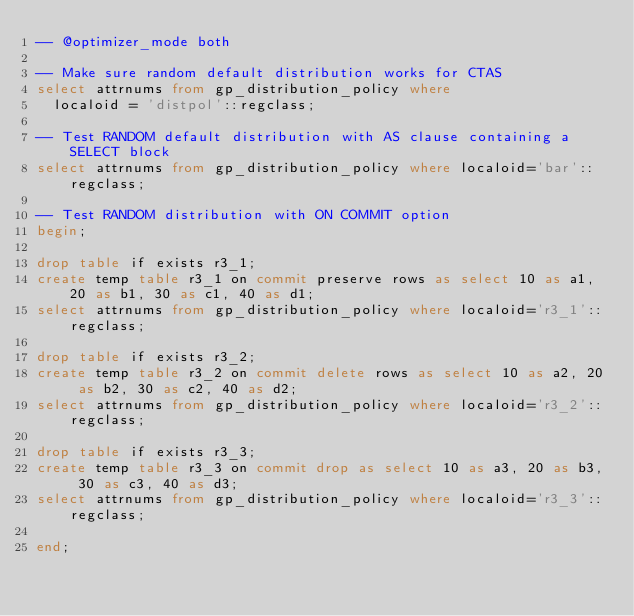Convert code to text. <code><loc_0><loc_0><loc_500><loc_500><_SQL_>-- @optimizer_mode both

-- Make sure random default distribution works for CTAS
select attrnums from gp_distribution_policy where
  localoid = 'distpol'::regclass;

-- Test RANDOM default distribution with AS clause containing a SELECT block
select attrnums from gp_distribution_policy where localoid='bar'::regclass;

-- Test RANDOM distribution with ON COMMIT option
begin;

drop table if exists r3_1;
create temp table r3_1 on commit preserve rows as select 10 as a1, 20 as b1, 30 as c1, 40 as d1;
select attrnums from gp_distribution_policy where localoid='r3_1'::regclass;

drop table if exists r3_2;
create temp table r3_2 on commit delete rows as select 10 as a2, 20 as b2, 30 as c2, 40 as d2;
select attrnums from gp_distribution_policy where localoid='r3_2'::regclass;

drop table if exists r3_3;
create temp table r3_3 on commit drop as select 10 as a3, 20 as b3, 30 as c3, 40 as d3;
select attrnums from gp_distribution_policy where localoid='r3_3'::regclass;

end;
</code> 